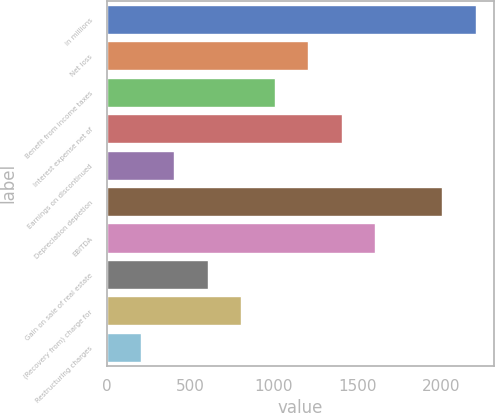<chart> <loc_0><loc_0><loc_500><loc_500><bar_chart><fcel>in millions<fcel>Net loss<fcel>Benefit from income taxes<fcel>Interest expense net of<fcel>Earnings on discontinued<fcel>Depreciation depletion<fcel>EBITDA<fcel>Gain on sale of real estate<fcel>(Recovery from) charge for<fcel>Restructuring charges<nl><fcel>2210.78<fcel>1206.78<fcel>1005.98<fcel>1407.58<fcel>403.58<fcel>2009.98<fcel>1608.38<fcel>604.38<fcel>805.18<fcel>202.78<nl></chart> 